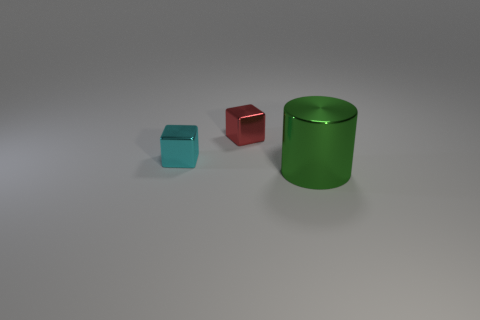What number of large green cylinders are there? There is one large green cylinder in the image, positioned on the right side, with a smooth surface reflecting ambient light. 